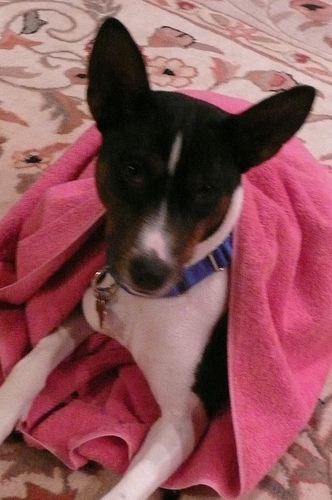<image>
Can you confirm if the dog is in the turkey? No. The dog is not contained within the turkey. These objects have a different spatial relationship. Is there a baby girl in the stroller? No. The baby girl is not contained within the stroller. These objects have a different spatial relationship. Is the dog behind the rug? No. The dog is not behind the rug. From this viewpoint, the dog appears to be positioned elsewhere in the scene. Is there a towel on the dog? Yes. Looking at the image, I can see the towel is positioned on top of the dog, with the dog providing support. 